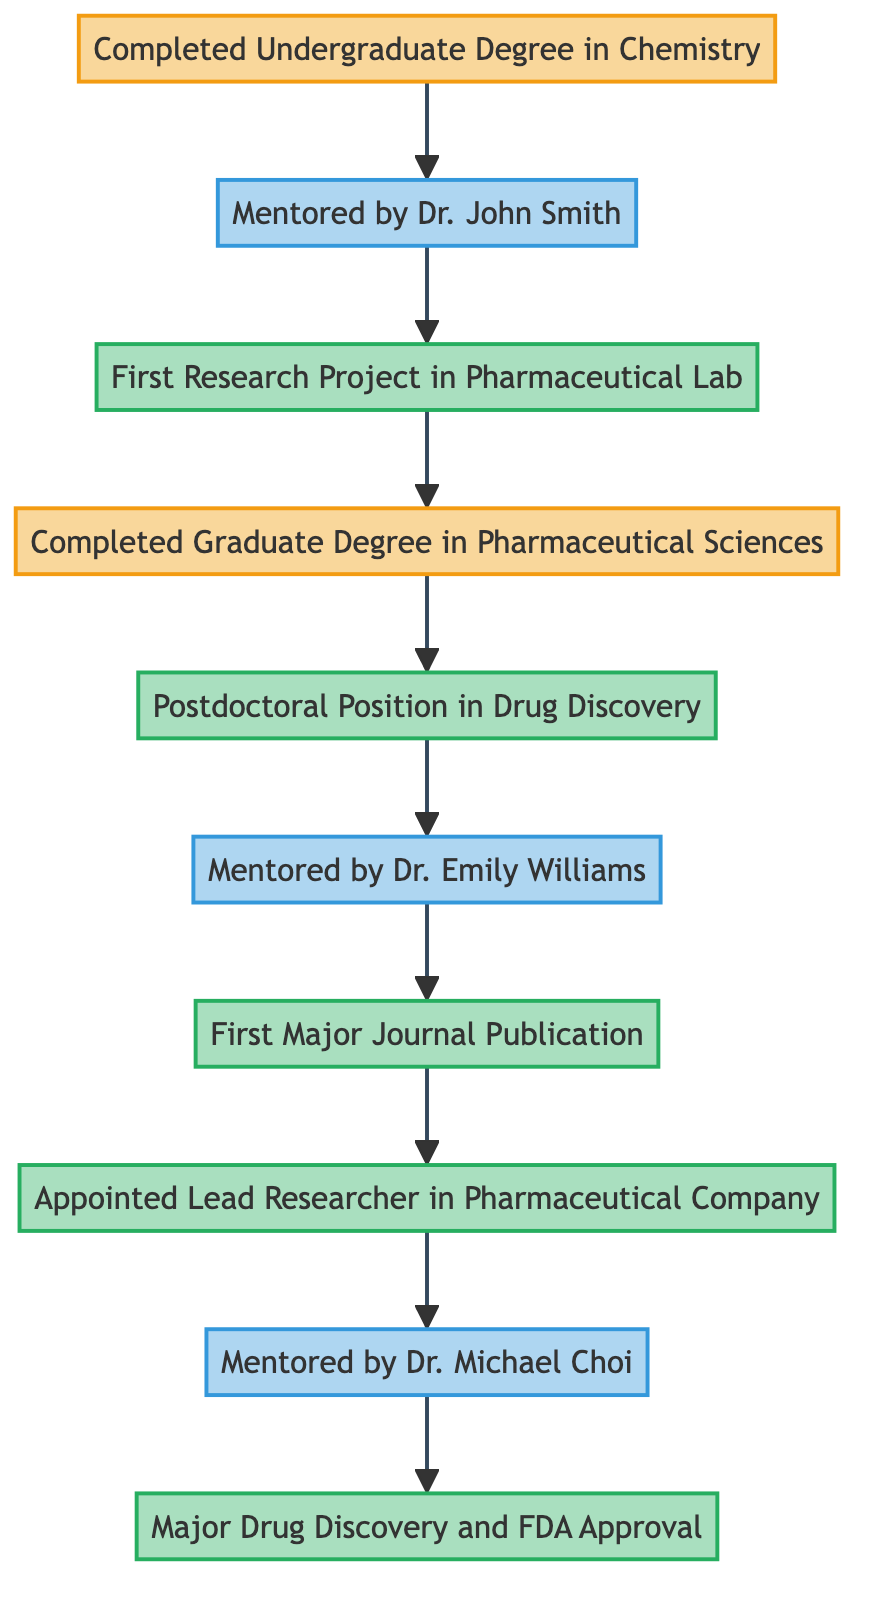What is the first mentorship in the career progression? The first mentorship mentioned in the diagram is connected to the "Completed Undergraduate Degree in Chemistry" node, which leads to "Mentored by Dr. John Smith." Thus, that is the initial mentorship in the career progression.
Answer: Mentored by Dr. John Smith How many professional milestones are indicated in the diagram? The professional milestones include "First Research Project in Pharmaceutical Lab," "Postdoctoral Position in Drug Discovery," "First Major Journal Publication," "Appointed Lead Researcher in Pharmaceutical Company," and "Major Drug Discovery and FDA Approval." Counting these gives a total of 5 professional milestones.
Answer: 5 What is the relationship between "First Research Project in Pharmaceutical Lab" and "Completed Graduate Degree in Pharmaceutical Sciences"? The "First Research Project in Pharmaceutical Lab" node flows into the "Completed Graduate Degree in Pharmaceutical Sciences" node, indicating that the research project is a step that leads to the completion of the graduate degree.
Answer: Leads to Who mentored the researcher during the postdoctoral position? The diagram shows that after the "Postdoctoral Position in Drug Discovery," the researcher was mentored by "Dr. Emily Williams." Thus, Dr. Williams was the mentor during this stage.
Answer: Dr. Emily Williams Which node directly follows "Lead Researcher in Pharmaceutical Company"? According to the diagram, "Mentored by Dr. Michael Choi" comes directly after the "Lead Researcher in Pharmaceutical Company," indicating that this mentorship follows the lead researcher position.
Answer: Mentored by Dr. Michael Choi What academic milestone precedes the "Postdoctoral Position in Drug Discovery"? The "Completed Graduate Degree in Pharmaceutical Sciences" is the academic milestone that comes right before "Postdoctoral Position in Drug Discovery" in the progression.
Answer: Completed Graduate Degree in Pharmaceutical Sciences What is the last professional milestone before obtaining FDA approval? The last professional milestone mentioned before the "Major Drug Discovery and FDA Approval" is the "Lead Researcher in Pharmaceutical Company," indicating a direct connection in the career path leading to FDA approval.
Answer: Appointed Lead Researcher in Pharmaceutical Company How many mentorship nodes are present in the diagram? The diagram includes three mentorship nodes: "Mentored by Dr. John Smith," "Mentored by Dr. Emily Williams," and "Mentored by Dr. Michael Choi." Therefore, there are a total of 3 mentorship nodes.
Answer: 3 